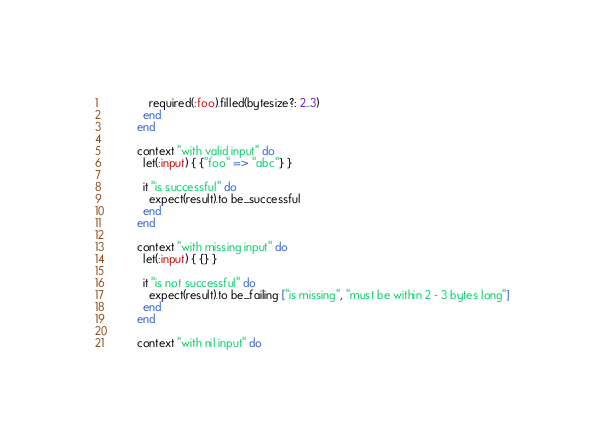Convert code to text. <code><loc_0><loc_0><loc_500><loc_500><_Ruby_>              required(:foo).filled(bytesize?: 2..3)
            end
          end

          context "with valid input" do
            let(:input) { {"foo" => "abc"} }

            it "is successful" do
              expect(result).to be_successful
            end
          end

          context "with missing input" do
            let(:input) { {} }

            it "is not successful" do
              expect(result).to be_failing ["is missing", "must be within 2 - 3 bytes long"]
            end
          end

          context "with nil input" do</code> 